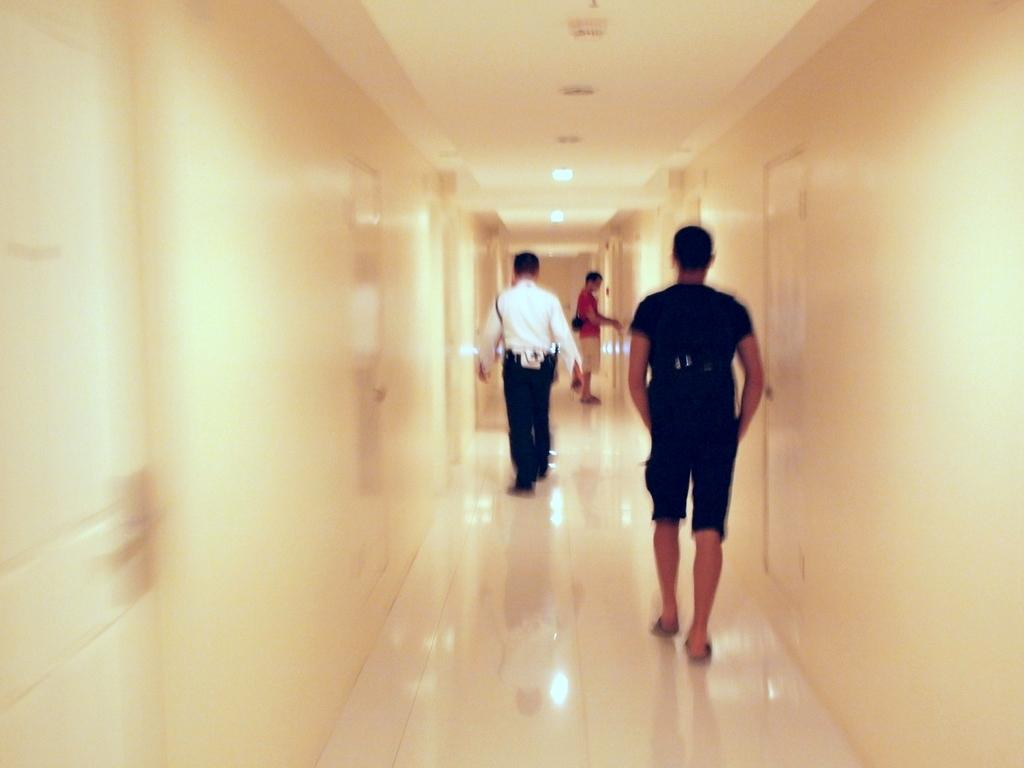What are the people in the image doing? The people in the image are walking. Where are the people walking? The people are walking on a path. What can be seen on either side of the path? There are walls on either side of the path. What is above the path in the image? There is a ceiling visible in the image. What provides illumination in the image? There are lights present in the image. What story is the monkey telling the owner in the image? There is no monkey or owner present in the image, so no such storytelling can be observed. 